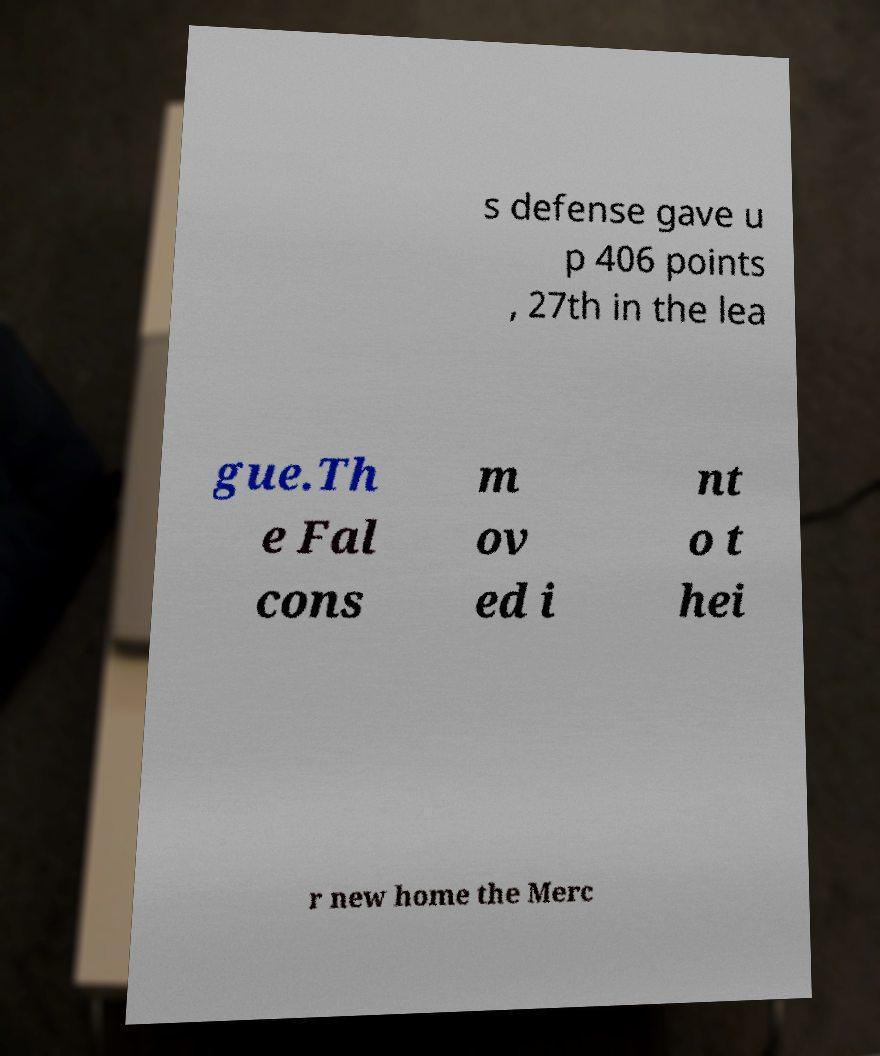Can you accurately transcribe the text from the provided image for me? s defense gave u p 406 points , 27th in the lea gue.Th e Fal cons m ov ed i nt o t hei r new home the Merc 